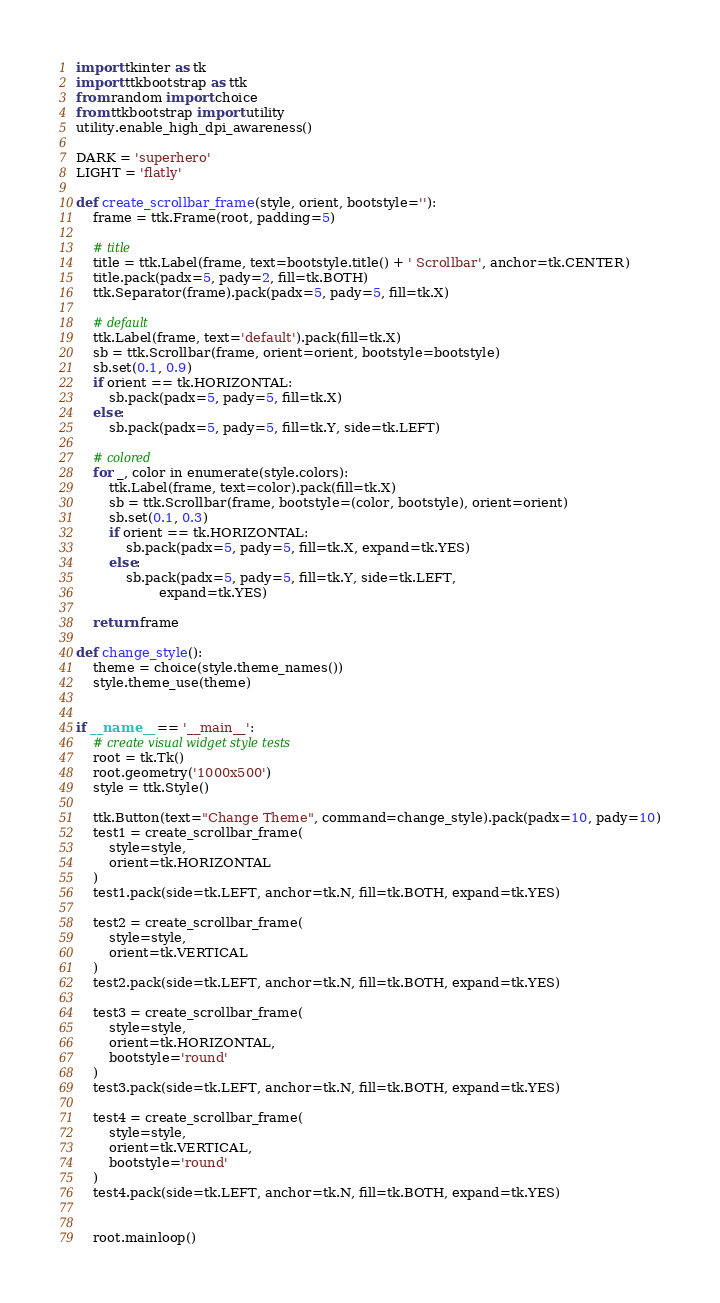<code> <loc_0><loc_0><loc_500><loc_500><_Python_>import tkinter as tk
import ttkbootstrap as ttk
from random import choice
from ttkbootstrap import utility
utility.enable_high_dpi_awareness()

DARK = 'superhero'
LIGHT = 'flatly'

def create_scrollbar_frame(style, orient, bootstyle=''):
    frame = ttk.Frame(root, padding=5)
    
    # title
    title = ttk.Label(frame, text=bootstyle.title() + ' Scrollbar', anchor=tk.CENTER)
    title.pack(padx=5, pady=2, fill=tk.BOTH)
    ttk.Separator(frame).pack(padx=5, pady=5, fill=tk.X)

    # default
    ttk.Label(frame, text='default').pack(fill=tk.X)
    sb = ttk.Scrollbar(frame, orient=orient, bootstyle=bootstyle)
    sb.set(0.1, 0.9)
    if orient == tk.HORIZONTAL:
        sb.pack(padx=5, pady=5, fill=tk.X)
    else:
        sb.pack(padx=5, pady=5, fill=tk.Y, side=tk.LEFT)

    # colored
    for _, color in enumerate(style.colors):
        ttk.Label(frame, text=color).pack(fill=tk.X)
        sb = ttk.Scrollbar(frame, bootstyle=(color, bootstyle), orient=orient)
        sb.set(0.1, 0.3)
        if orient == tk.HORIZONTAL:
            sb.pack(padx=5, pady=5, fill=tk.X, expand=tk.YES)
        else:
            sb.pack(padx=5, pady=5, fill=tk.Y, side=tk.LEFT, 
                    expand=tk.YES)

    return frame

def change_style():
    theme = choice(style.theme_names())
    style.theme_use(theme)    


if __name__ == '__main__':
    # create visual widget style tests
    root = tk.Tk()
    root.geometry('1000x500')
    style = ttk.Style()

    ttk.Button(text="Change Theme", command=change_style).pack(padx=10, pady=10)
    test1 = create_scrollbar_frame(
        style=style, 
        orient=tk.HORIZONTAL
    )
    test1.pack(side=tk.LEFT, anchor=tk.N, fill=tk.BOTH, expand=tk.YES)
    
    test2 = create_scrollbar_frame(
        style=style, 
        orient=tk.VERTICAL
    )
    test2.pack(side=tk.LEFT, anchor=tk.N, fill=tk.BOTH, expand=tk.YES)

    test3 = create_scrollbar_frame(
        style=style, 
        orient=tk.HORIZONTAL,
        bootstyle='round'
    )
    test3.pack(side=tk.LEFT, anchor=tk.N, fill=tk.BOTH, expand=tk.YES)
    
    test4 = create_scrollbar_frame(
        style=style, 
        orient=tk.VERTICAL,
        bootstyle='round'
    )
    test4.pack(side=tk.LEFT, anchor=tk.N, fill=tk.BOTH, expand=tk.YES)


    root.mainloop()</code> 